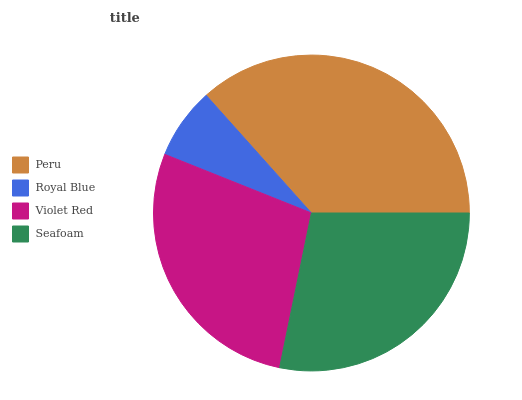Is Royal Blue the minimum?
Answer yes or no. Yes. Is Peru the maximum?
Answer yes or no. Yes. Is Violet Red the minimum?
Answer yes or no. No. Is Violet Red the maximum?
Answer yes or no. No. Is Violet Red greater than Royal Blue?
Answer yes or no. Yes. Is Royal Blue less than Violet Red?
Answer yes or no. Yes. Is Royal Blue greater than Violet Red?
Answer yes or no. No. Is Violet Red less than Royal Blue?
Answer yes or no. No. Is Seafoam the high median?
Answer yes or no. Yes. Is Violet Red the low median?
Answer yes or no. Yes. Is Peru the high median?
Answer yes or no. No. Is Peru the low median?
Answer yes or no. No. 